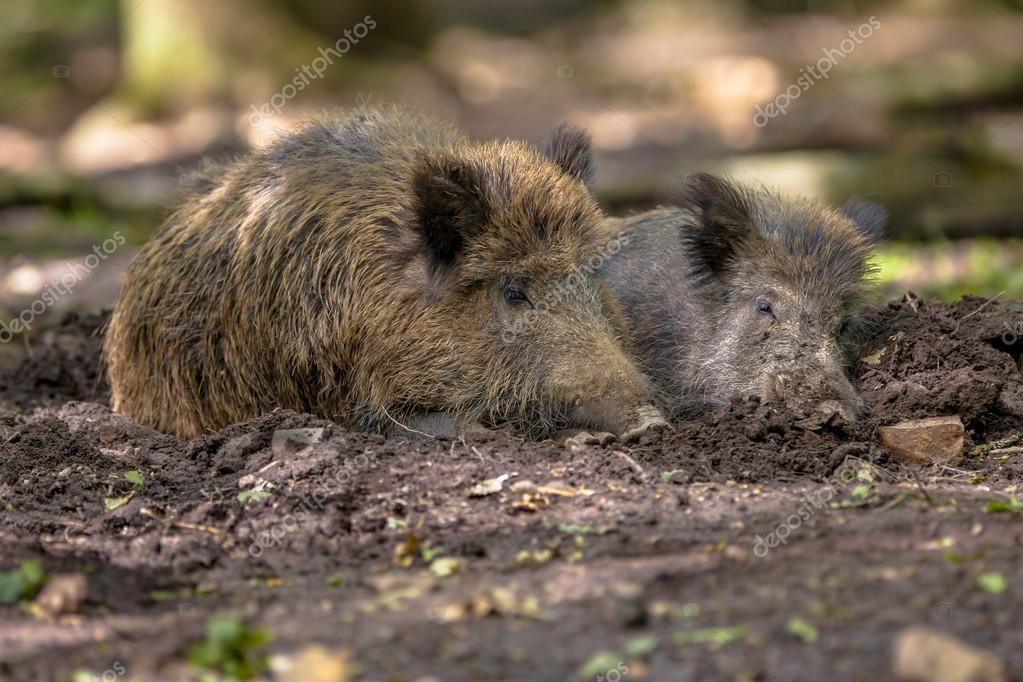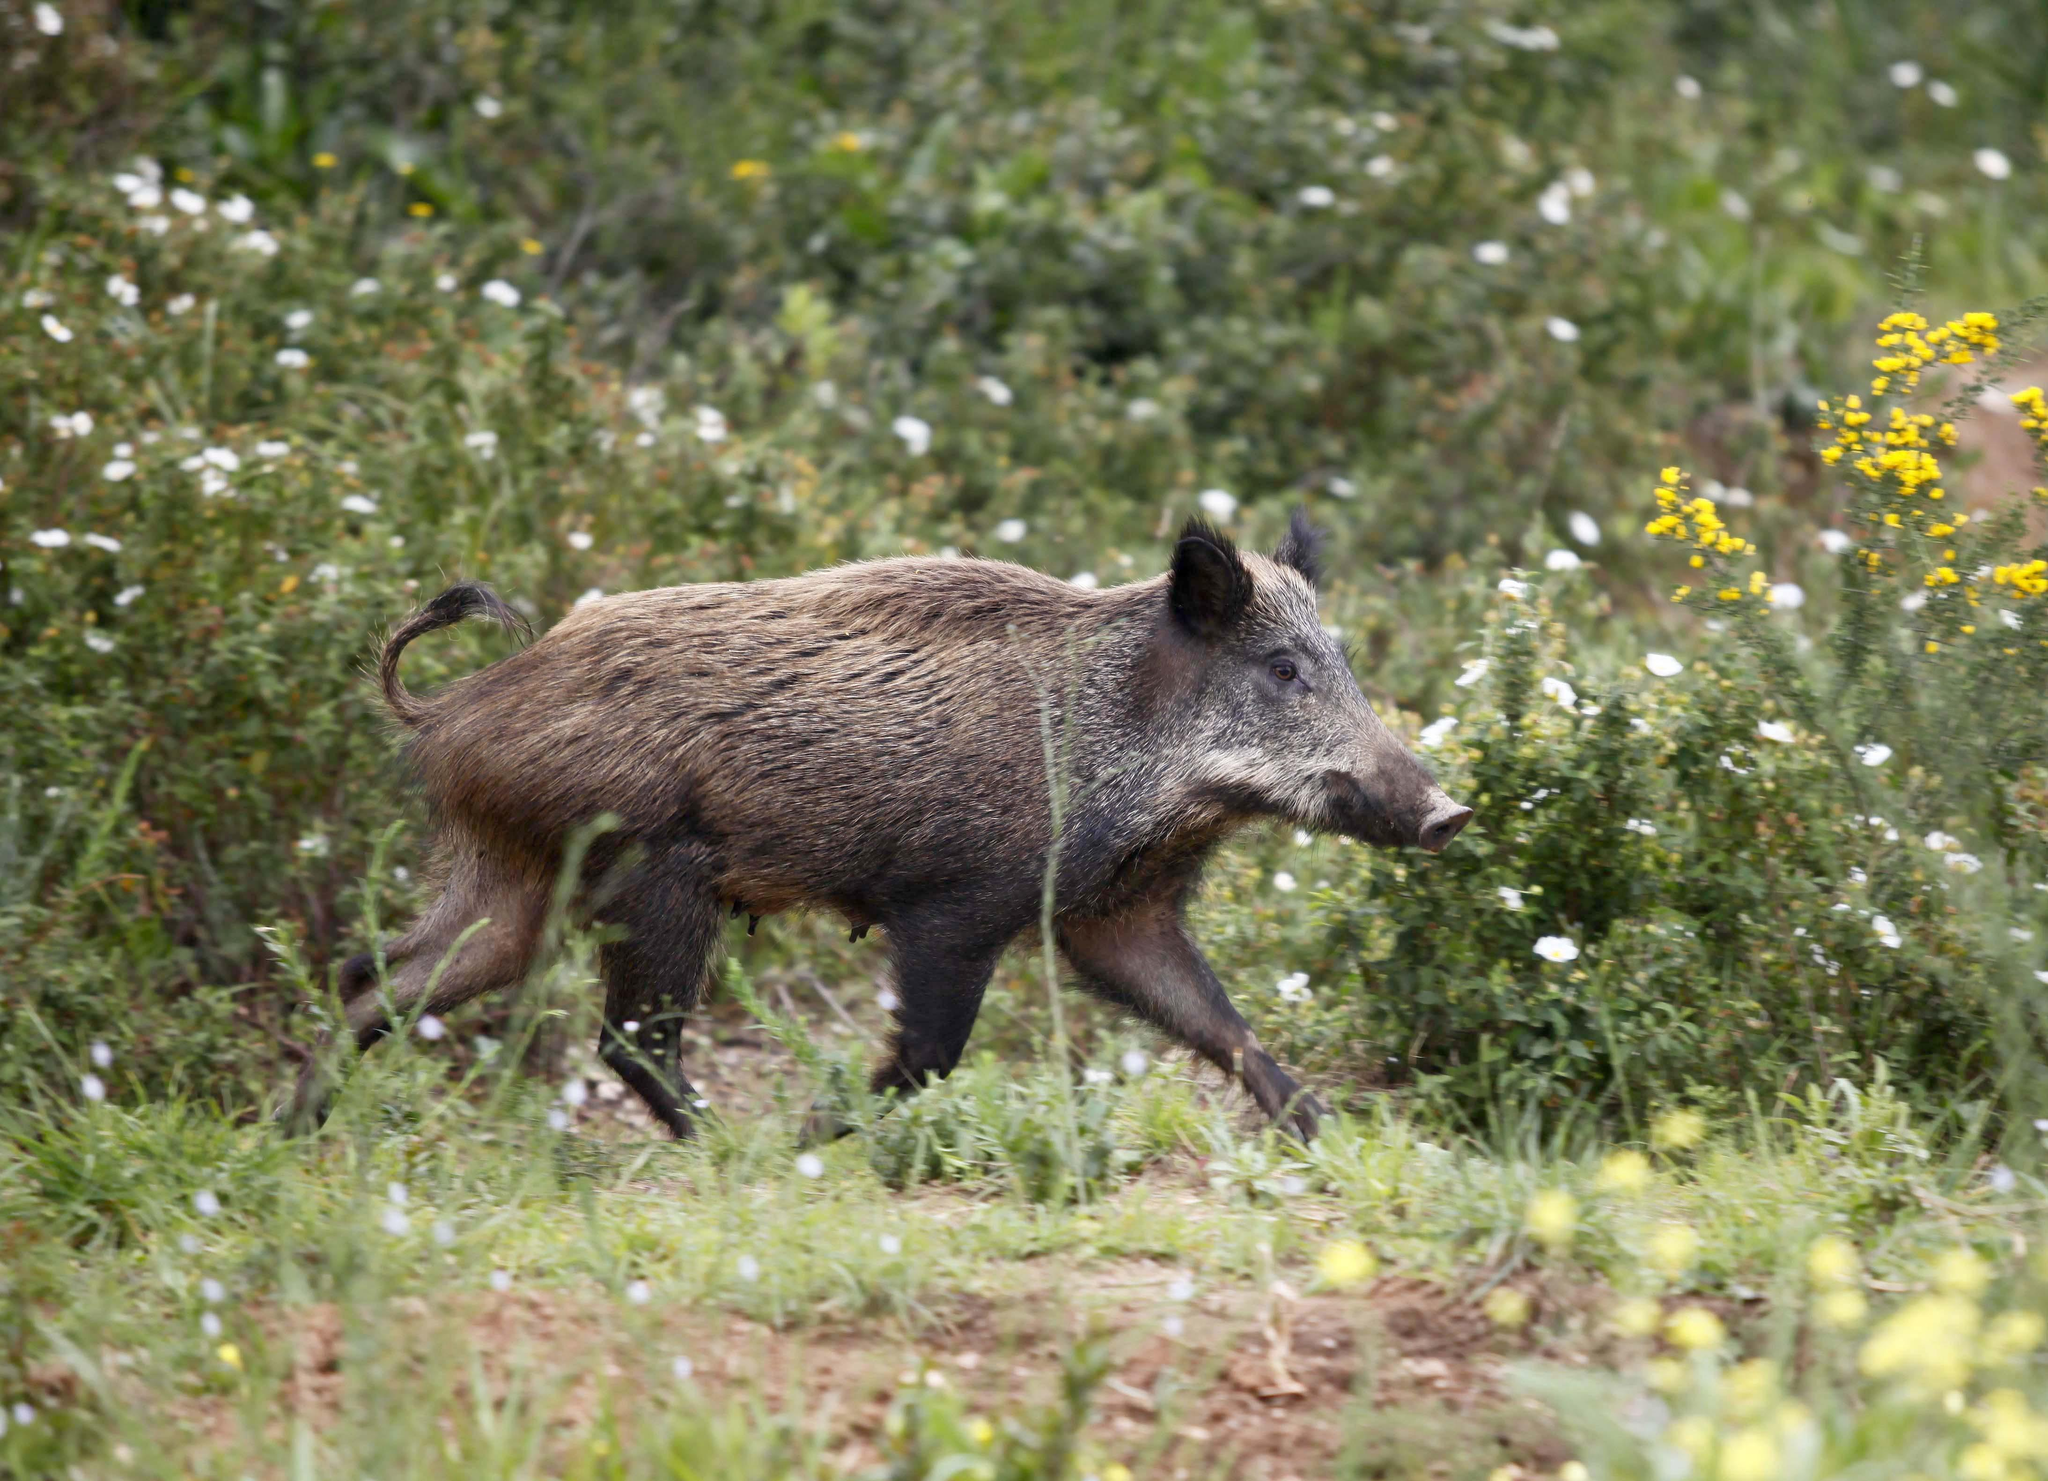The first image is the image on the left, the second image is the image on the right. For the images shown, is this caption "There are three hogs in the pair of images." true? Answer yes or no. Yes. The first image is the image on the left, the second image is the image on the right. For the images displayed, is the sentence "There are exactly three pigs." factually correct? Answer yes or no. Yes. 